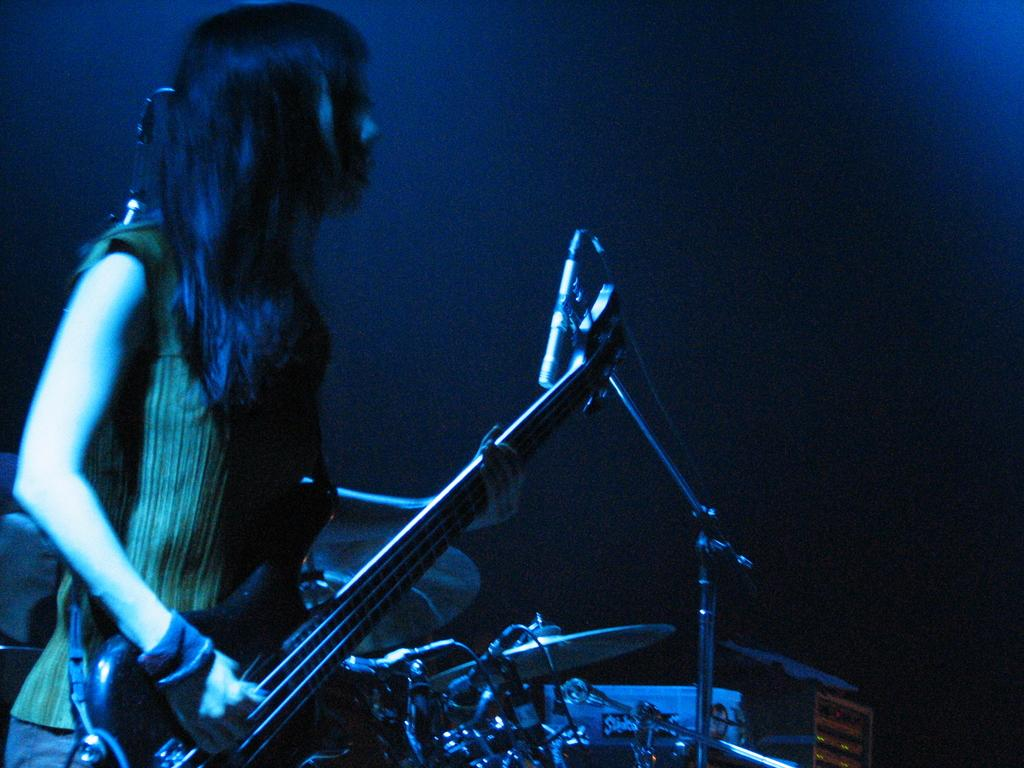Who is the main subject in the image? There is a woman in the image. What is the woman holding in the image? The woman is holding a guitar. What is the woman doing with the guitar? The woman is playing the guitar. What is in front of the woman? There is a microphone in front of the woman. What other musical instruments can be seen in the image? There are other musical instruments in the image. What type of poison is the woman using to play the guitar in the image? There is no poison present in the image; the woman is playing the guitar using her hands and fingers. 